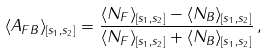Convert formula to latex. <formula><loc_0><loc_0><loc_500><loc_500>\langle A _ { F B } \rangle _ { [ s _ { 1 } , s _ { 2 } ] } = \frac { \langle N _ { F } \rangle _ { [ s _ { 1 } , s _ { 2 } ] } - \langle N _ { B } \rangle _ { [ s _ { 1 } , s _ { 2 } ] } } { \langle N _ { F } \rangle _ { [ s _ { 1 } , s _ { 2 } ] } + \langle N _ { B } \rangle _ { [ s _ { 1 } , s _ { 2 } ] } } \, ,</formula> 